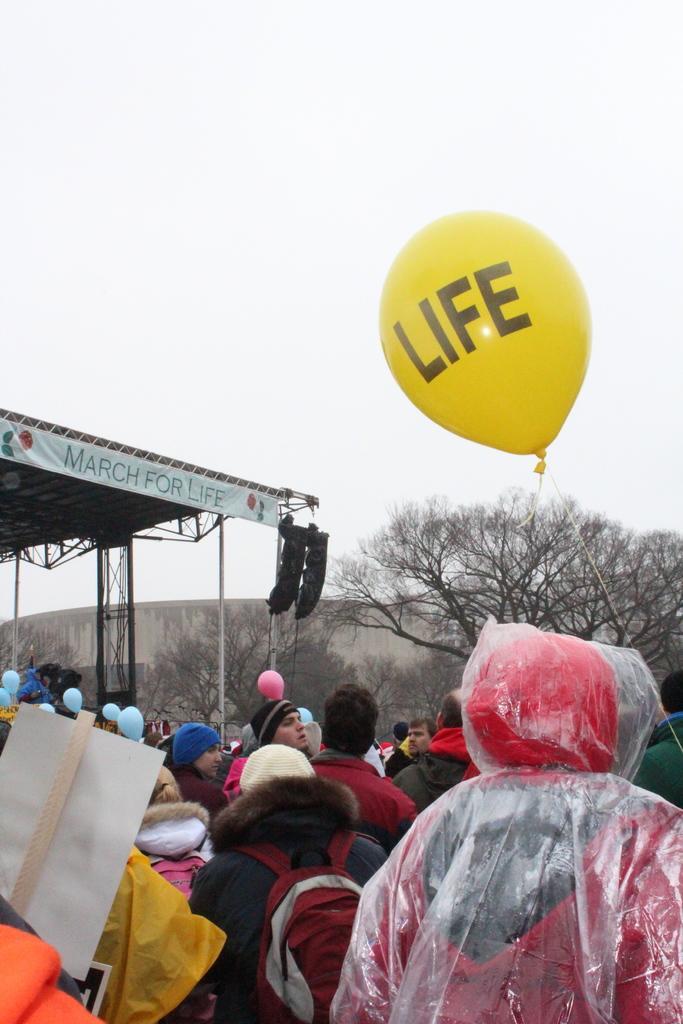In one or two sentences, can you explain what this image depicts? In this picture I can see there are few people standing and they are wearing coats and hoodies and there is a banner on to left and there are trees in the backdrop. There is a yellow balloon here and there is something written on it and the sky is clear. 